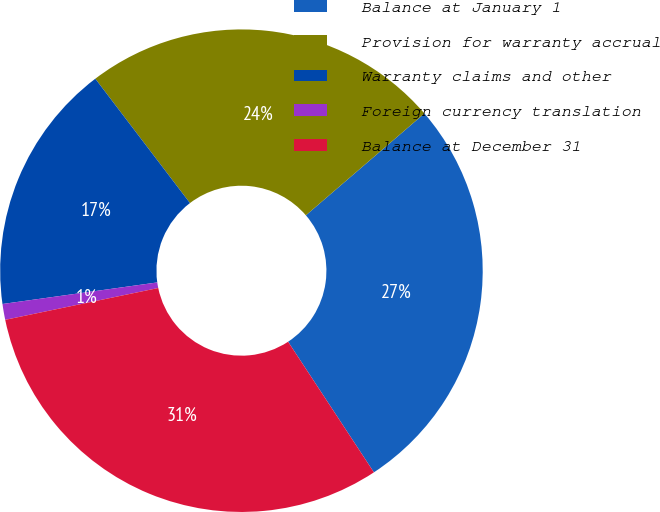Convert chart to OTSL. <chart><loc_0><loc_0><loc_500><loc_500><pie_chart><fcel>Balance at January 1<fcel>Provision for warranty accrual<fcel>Warranty claims and other<fcel>Foreign currency translation<fcel>Balance at December 31<nl><fcel>27.05%<fcel>24.06%<fcel>16.85%<fcel>1.06%<fcel>30.99%<nl></chart> 